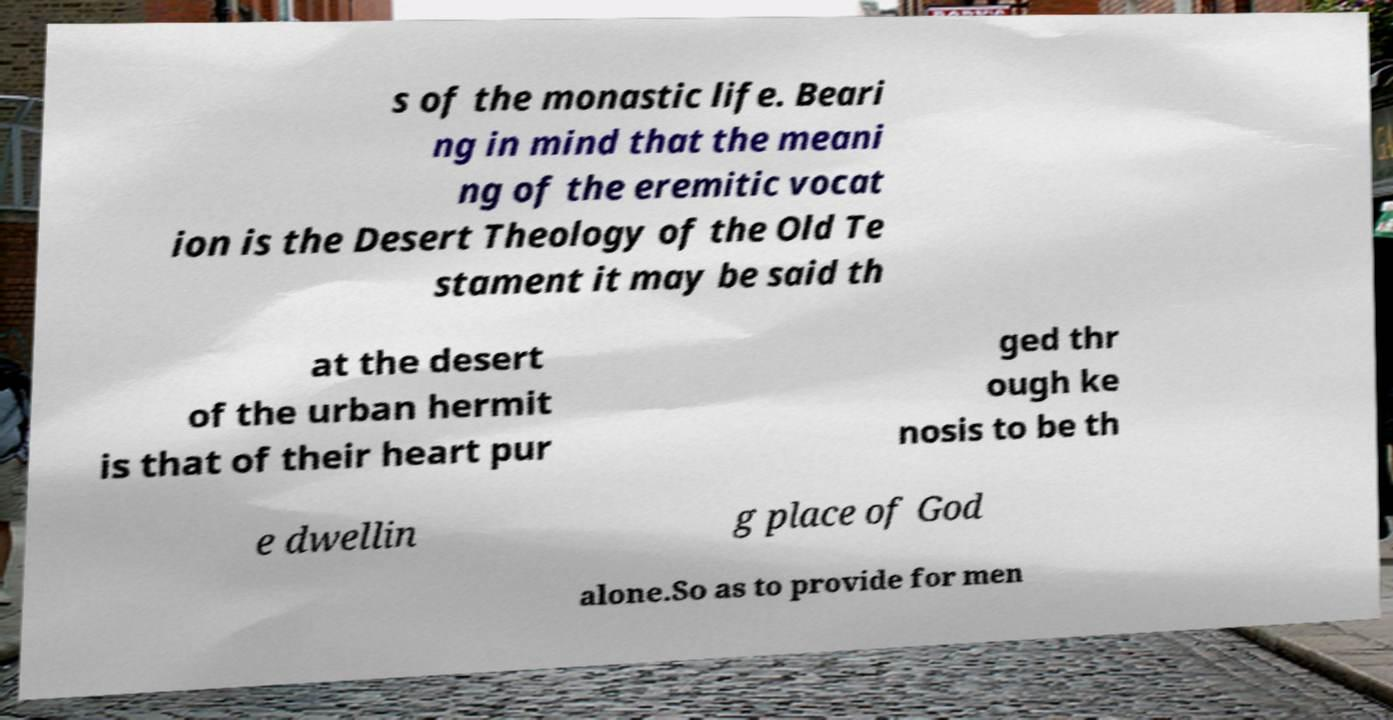Can you accurately transcribe the text from the provided image for me? s of the monastic life. Beari ng in mind that the meani ng of the eremitic vocat ion is the Desert Theology of the Old Te stament it may be said th at the desert of the urban hermit is that of their heart pur ged thr ough ke nosis to be th e dwellin g place of God alone.So as to provide for men 